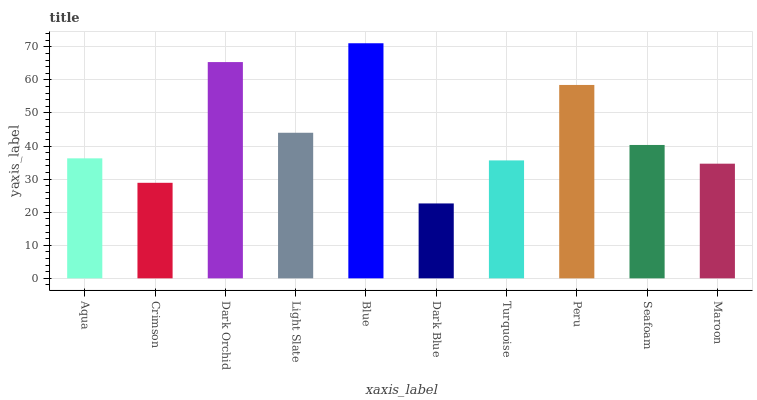Is Crimson the minimum?
Answer yes or no. No. Is Crimson the maximum?
Answer yes or no. No. Is Aqua greater than Crimson?
Answer yes or no. Yes. Is Crimson less than Aqua?
Answer yes or no. Yes. Is Crimson greater than Aqua?
Answer yes or no. No. Is Aqua less than Crimson?
Answer yes or no. No. Is Seafoam the high median?
Answer yes or no. Yes. Is Aqua the low median?
Answer yes or no. Yes. Is Turquoise the high median?
Answer yes or no. No. Is Dark Blue the low median?
Answer yes or no. No. 